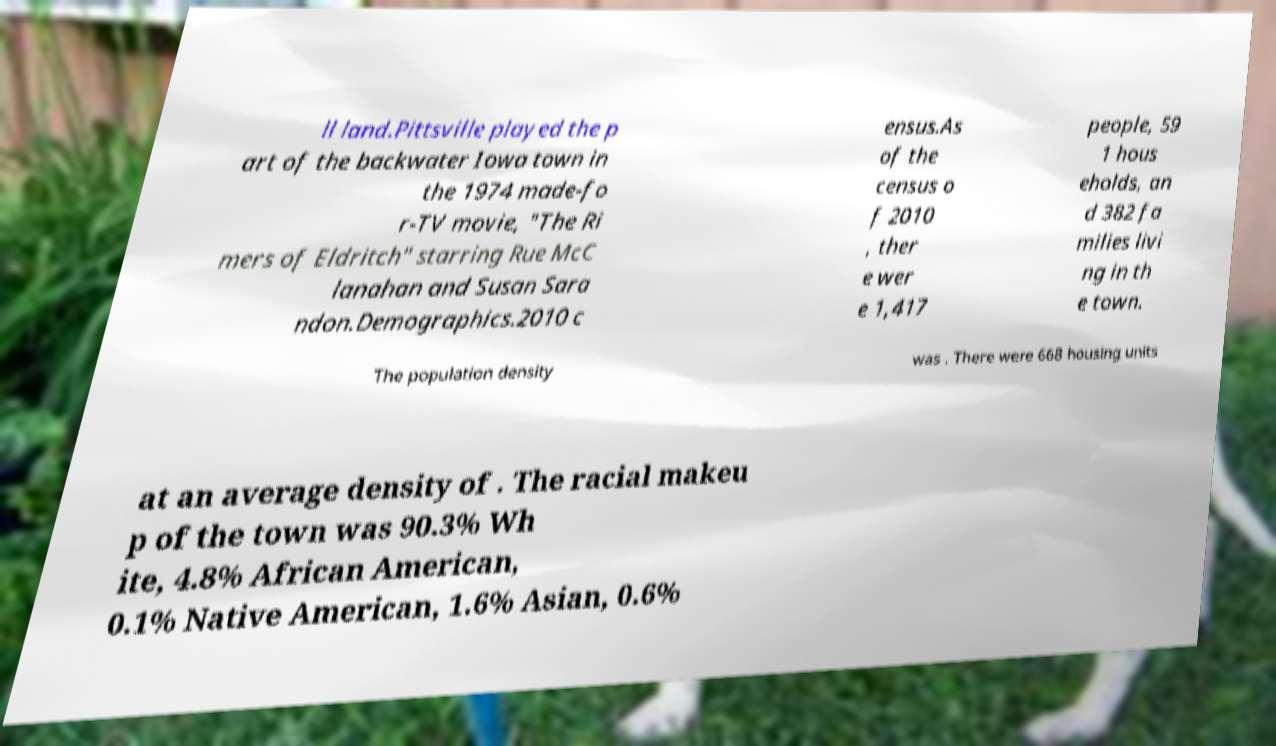Please identify and transcribe the text found in this image. ll land.Pittsville played the p art of the backwater Iowa town in the 1974 made-fo r-TV movie, "The Ri mers of Eldritch" starring Rue McC lanahan and Susan Sara ndon.Demographics.2010 c ensus.As of the census o f 2010 , ther e wer e 1,417 people, 59 1 hous eholds, an d 382 fa milies livi ng in th e town. The population density was . There were 668 housing units at an average density of . The racial makeu p of the town was 90.3% Wh ite, 4.8% African American, 0.1% Native American, 1.6% Asian, 0.6% 